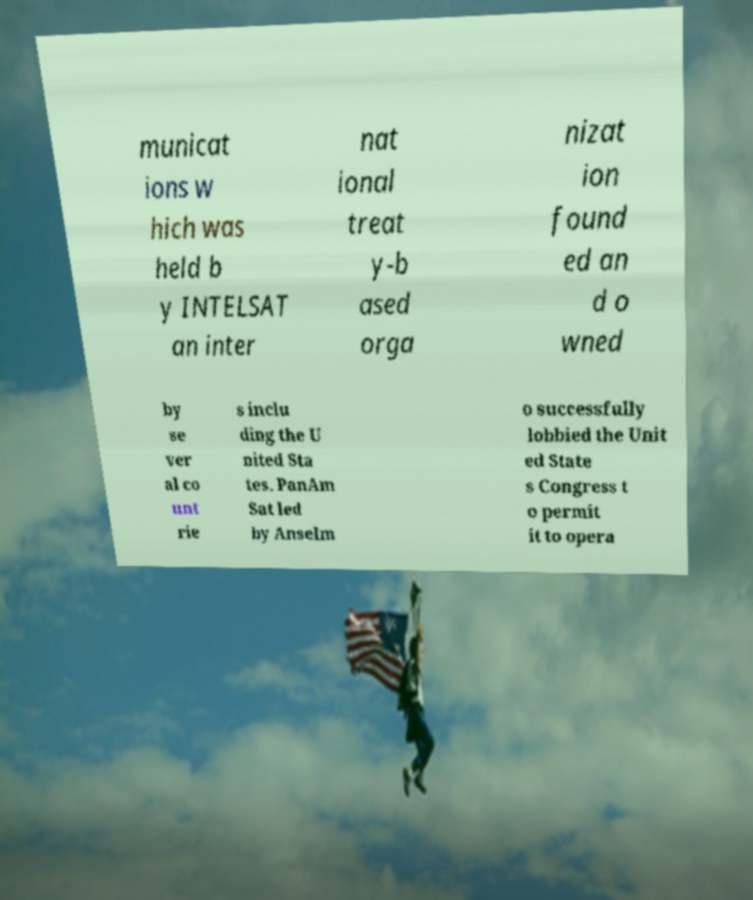Can you read and provide the text displayed in the image?This photo seems to have some interesting text. Can you extract and type it out for me? municat ions w hich was held b y INTELSAT an inter nat ional treat y-b ased orga nizat ion found ed an d o wned by se ver al co unt rie s inclu ding the U nited Sta tes. PanAm Sat led by Anselm o successfully lobbied the Unit ed State s Congress t o permit it to opera 